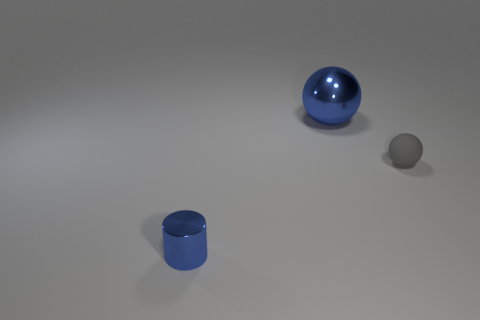Add 1 large purple matte objects. How many objects exist? 4 Subtract all cylinders. How many objects are left? 2 Subtract 0 red spheres. How many objects are left? 3 Subtract all tiny blue blocks. Subtract all spheres. How many objects are left? 1 Add 2 gray spheres. How many gray spheres are left? 3 Add 1 blue balls. How many blue balls exist? 2 